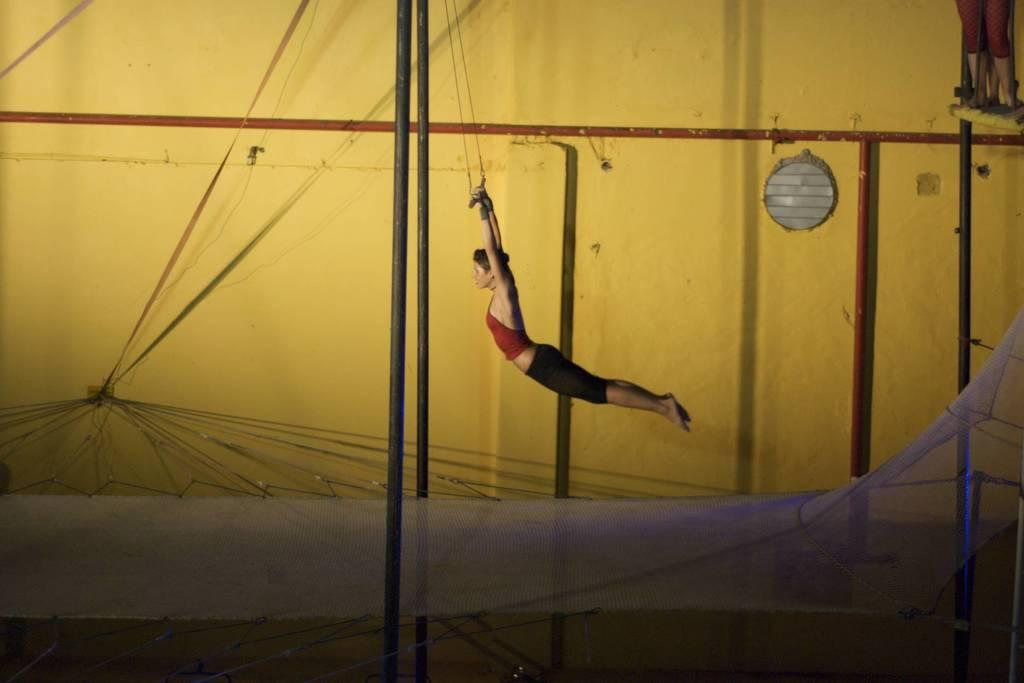What is the main subject of the image? The main subject of the image is a woman. What is the woman doing in the image? The woman is doing exercise in the image. What can be seen at the bottom of the image? There is a net at the bottom of the image. What is visible in the background of the image? There is a wall and rods in the background of the image. What type of brain can be seen in the image? There is no brain present in the image; it features a woman doing exercise. How does the woman sort the rods in the image? There is no indication in the image that the woman is sorting rods, as the rods are in the background and not directly related to her exercise. 